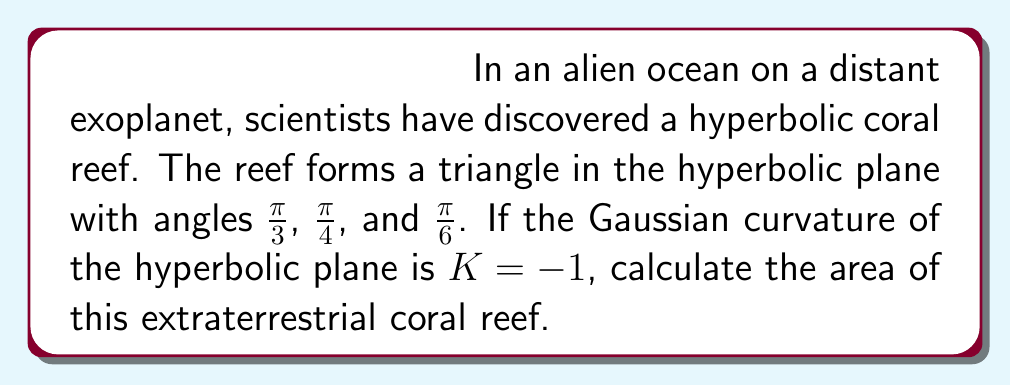Show me your answer to this math problem. To solve this problem, we'll use the Gauss-Bonnet formula for hyperbolic triangles. The steps are as follows:

1) The Gauss-Bonnet formula for a hyperbolic triangle states:

   $$A = -K(\alpha + \beta + \gamma - \pi)$$

   Where $A$ is the area, $K$ is the Gaussian curvature, and $\alpha$, $\beta$, and $\gamma$ are the angles of the triangle.

2) We're given that $K = -1$, so our formula becomes:

   $$A = \alpha + \beta + \gamma - \pi$$

3) Substitute the given angles:

   $$A = \frac{\pi}{3} + \frac{\pi}{4} + \frac{\pi}{6} - \pi$$

4) Add the fractions:

   $$A = \frac{4\pi}{12} + \frac{3\pi}{12} + \frac{2\pi}{12} - \frac{12\pi}{12}$$

   $$A = \frac{9\pi}{12} - \frac{12\pi}{12}$$

5) Simplify:

   $$A = -\frac{3\pi}{12} = -\frac{\pi}{4}$$

6) Since area is always positive, we take the absolute value:

   $$A = \frac{\pi}{4}$$

This result shows that the area of the hyperbolic coral reef is $\frac{\pi}{4}$ square units in the hyperbolic plane.
Answer: $\frac{\pi}{4}$ square units 